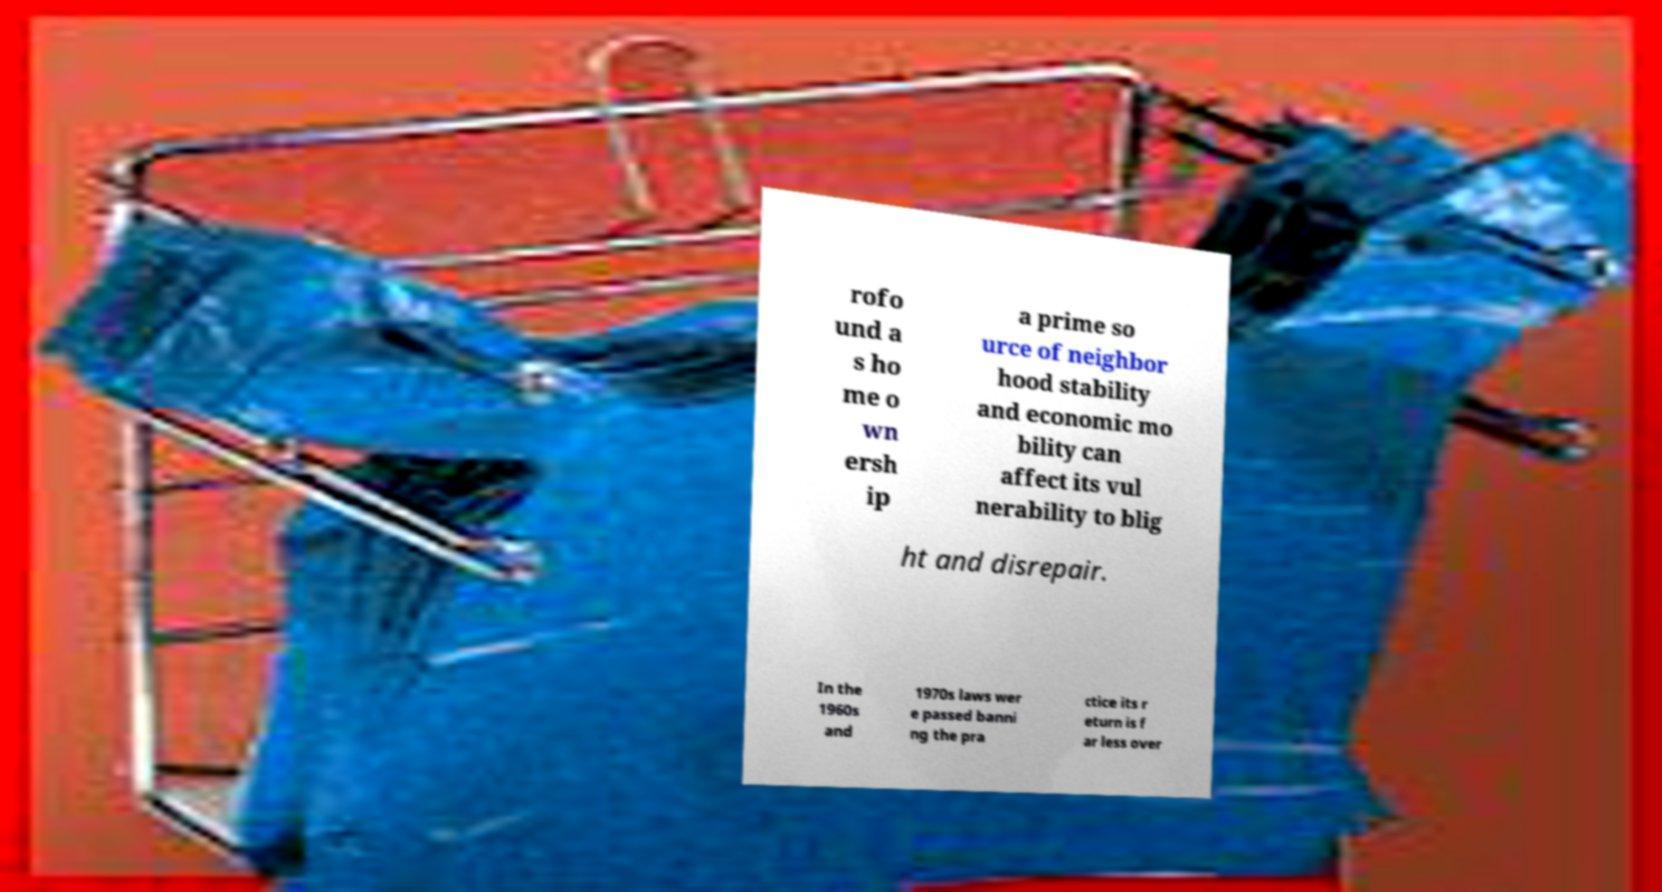Could you assist in decoding the text presented in this image and type it out clearly? rofo und a s ho me o wn ersh ip a prime so urce of neighbor hood stability and economic mo bility can affect its vul nerability to blig ht and disrepair. In the 1960s and 1970s laws wer e passed banni ng the pra ctice its r eturn is f ar less over 